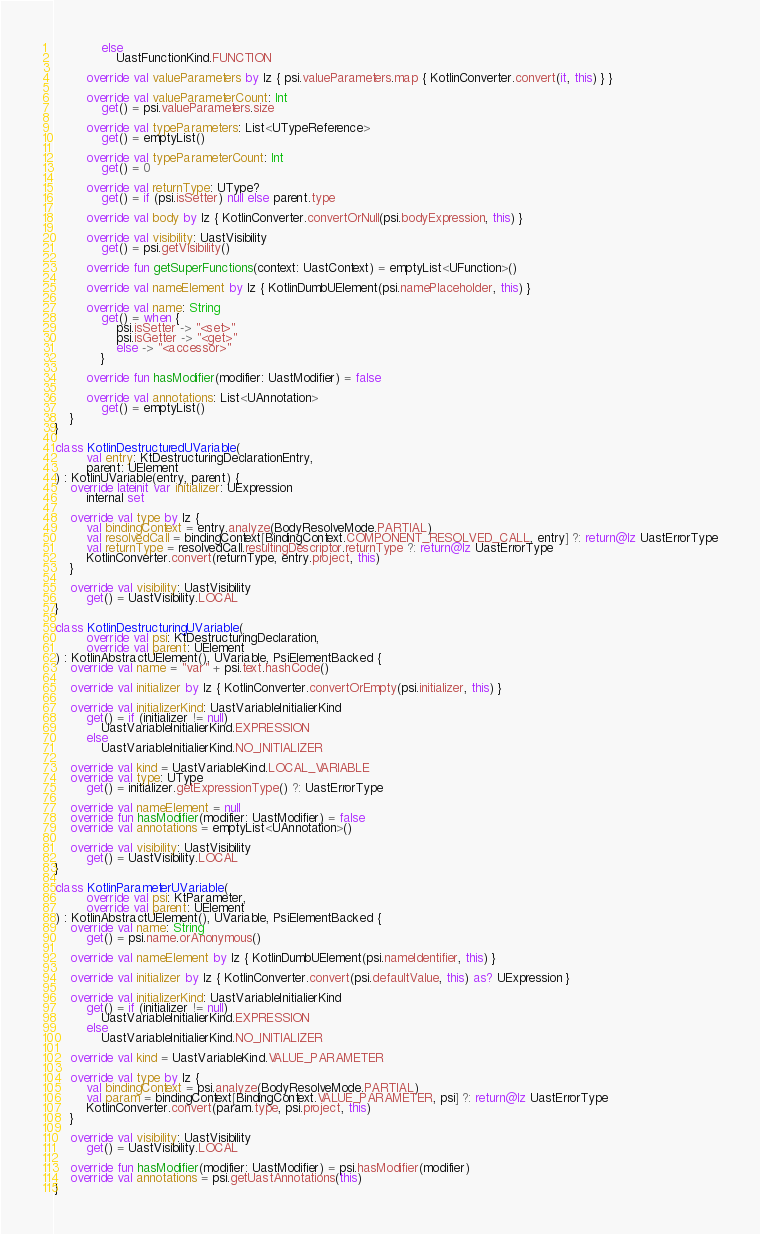Convert code to text. <code><loc_0><loc_0><loc_500><loc_500><_Kotlin_>            else
                UastFunctionKind.FUNCTION

        override val valueParameters by lz { psi.valueParameters.map { KotlinConverter.convert(it, this) } }

        override val valueParameterCount: Int
            get() = psi.valueParameters.size

        override val typeParameters: List<UTypeReference>
            get() = emptyList()

        override val typeParameterCount: Int
            get() = 0

        override val returnType: UType?
            get() = if (psi.isSetter) null else parent.type

        override val body by lz { KotlinConverter.convertOrNull(psi.bodyExpression, this) }

        override val visibility: UastVisibility
            get() = psi.getVisibility()

        override fun getSuperFunctions(context: UastContext) = emptyList<UFunction>()

        override val nameElement by lz { KotlinDumbUElement(psi.namePlaceholder, this) }

        override val name: String
            get() = when {
                psi.isSetter -> "<set>"
                psi.isGetter -> "<get>"
                else -> "<accessor>"
            }

        override fun hasModifier(modifier: UastModifier) = false

        override val annotations: List<UAnnotation>
            get() = emptyList()
    }
}

class KotlinDestructuredUVariable(
        val entry: KtDestructuringDeclarationEntry,
        parent: UElement
) : KotlinUVariable(entry, parent) {
    override lateinit var initializer: UExpression
        internal set

    override val type by lz {
        val bindingContext = entry.analyze(BodyResolveMode.PARTIAL)
        val resolvedCall = bindingContext[BindingContext.COMPONENT_RESOLVED_CALL, entry] ?: return@lz UastErrorType
        val returnType = resolvedCall.resultingDescriptor.returnType ?: return@lz UastErrorType
        KotlinConverter.convert(returnType, entry.project, this)
    }

    override val visibility: UastVisibility
        get() = UastVisibility.LOCAL
}

class KotlinDestructuringUVariable(
        override val psi: KtDestructuringDeclaration,
        override val parent: UElement
) : KotlinAbstractUElement(), UVariable, PsiElementBacked {
    override val name = "var" + psi.text.hashCode()

    override val initializer by lz { KotlinConverter.convertOrEmpty(psi.initializer, this) }

    override val initializerKind: UastVariableInitialierKind
        get() = if (initializer != null)
            UastVariableInitialierKind.EXPRESSION
        else
            UastVariableInitialierKind.NO_INITIALIZER

    override val kind = UastVariableKind.LOCAL_VARIABLE
    override val type: UType
        get() = initializer.getExpressionType() ?: UastErrorType

    override val nameElement = null
    override fun hasModifier(modifier: UastModifier) = false
    override val annotations = emptyList<UAnnotation>()

    override val visibility: UastVisibility
        get() = UastVisibility.LOCAL
}

class KotlinParameterUVariable(
        override val psi: KtParameter,
        override val parent: UElement
) : KotlinAbstractUElement(), UVariable, PsiElementBacked {
    override val name: String
        get() = psi.name.orAnonymous()

    override val nameElement by lz { KotlinDumbUElement(psi.nameIdentifier, this) }

    override val initializer by lz { KotlinConverter.convert(psi.defaultValue, this) as? UExpression }

    override val initializerKind: UastVariableInitialierKind
        get() = if (initializer != null)
            UastVariableInitialierKind.EXPRESSION
        else
            UastVariableInitialierKind.NO_INITIALIZER

    override val kind = UastVariableKind.VALUE_PARAMETER

    override val type by lz {
        val bindingContext = psi.analyze(BodyResolveMode.PARTIAL)
        val param = bindingContext[BindingContext.VALUE_PARAMETER, psi] ?: return@lz UastErrorType
        KotlinConverter.convert(param.type, psi.project, this)
    }

    override val visibility: UastVisibility
        get() = UastVisibility.LOCAL

    override fun hasModifier(modifier: UastModifier) = psi.hasModifier(modifier)
    override val annotations = psi.getUastAnnotations(this)
}</code> 